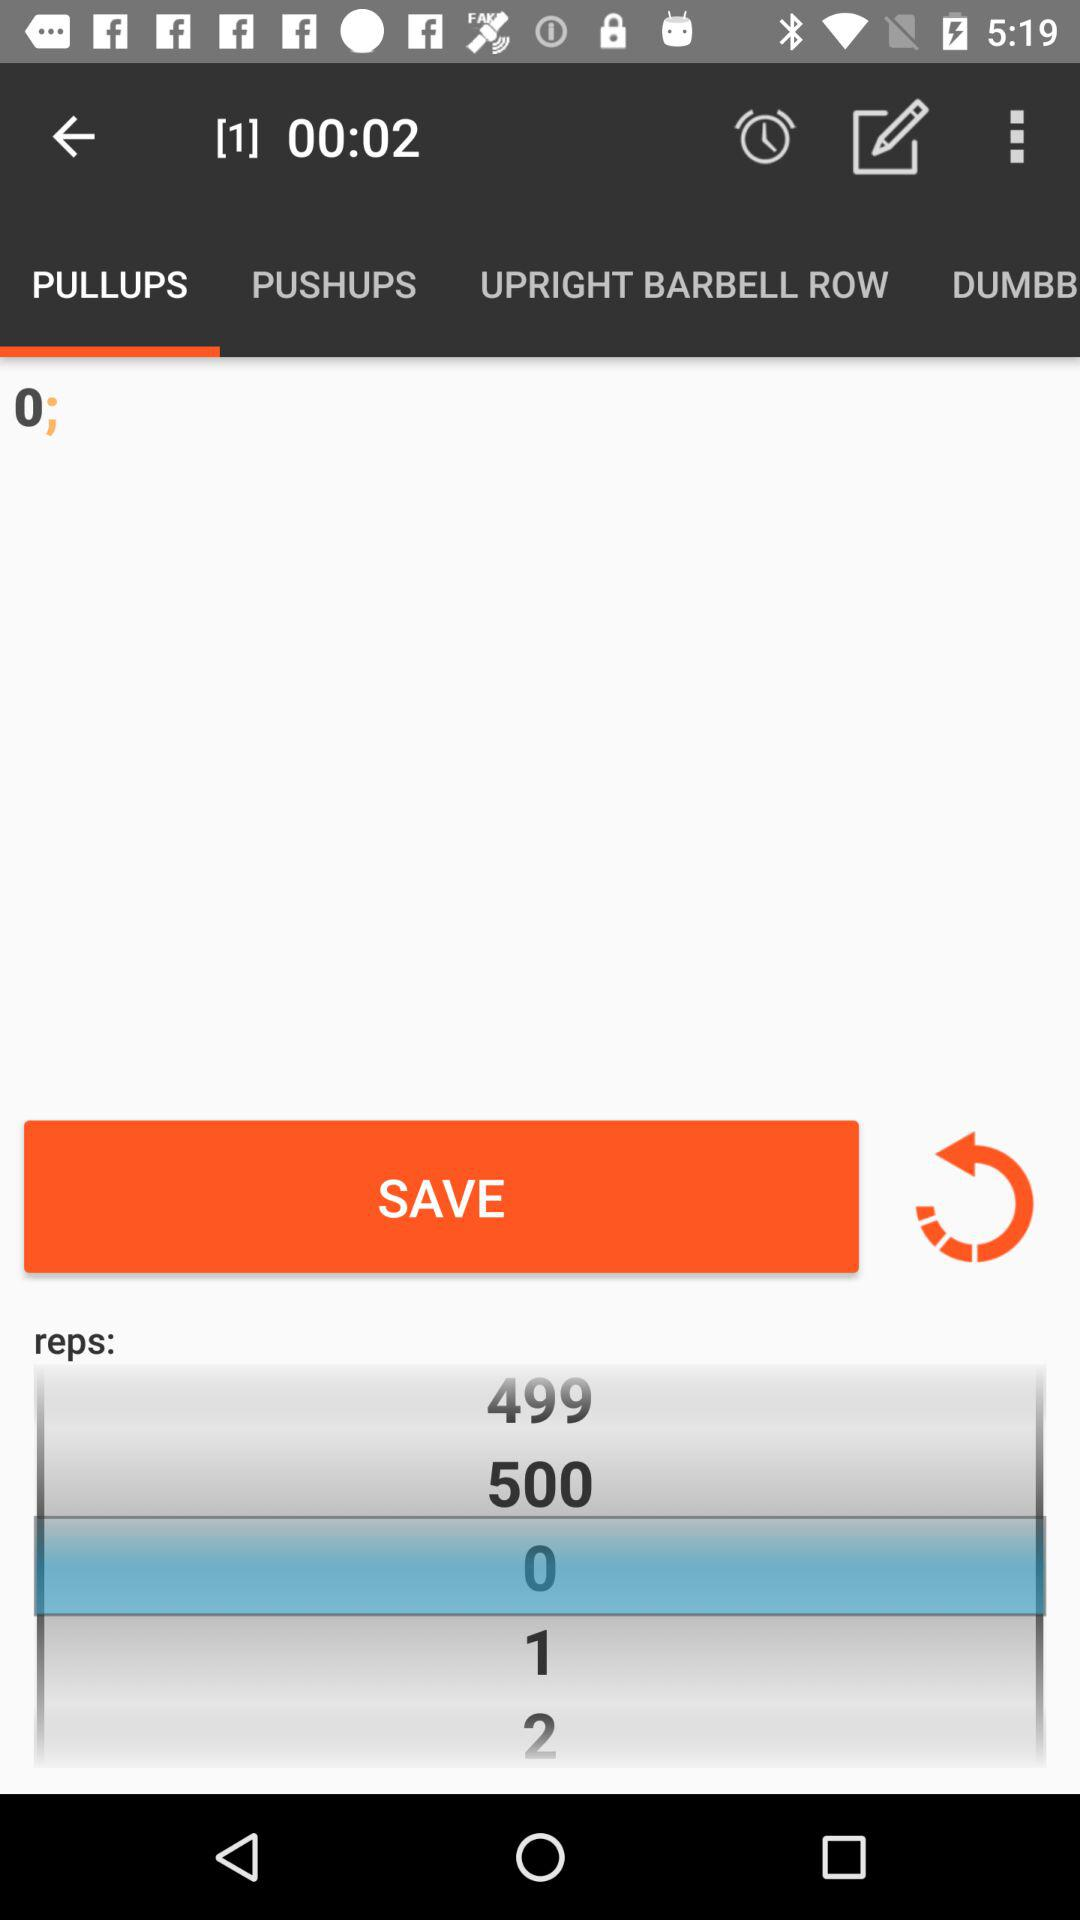Which tab is currently selected? The currently selected tab is "PULLUPS". 